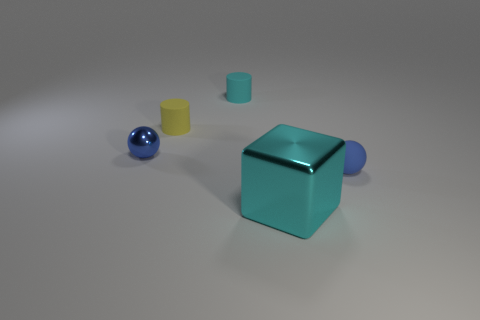How many cyan objects are in front of the yellow matte cylinder and behind the yellow cylinder?
Provide a short and direct response. 0. What number of objects are either cyan things that are in front of the tiny cyan thing or cyan things in front of the blue metallic ball?
Give a very brief answer. 1. What number of other things are there of the same size as the rubber sphere?
Ensure brevity in your answer.  3. There is a shiny thing to the right of the shiny object left of the large metal cube; what is its shape?
Offer a terse response. Cube. There is a metal thing that is behind the rubber ball; does it have the same color as the large metallic cube in front of the blue matte thing?
Provide a succinct answer. No. Are there any other things that are the same color as the large metal cube?
Your answer should be compact. Yes. What color is the small metal ball?
Your answer should be very brief. Blue. Are any large cyan rubber balls visible?
Your answer should be compact. No. There is a tiny yellow matte cylinder; are there any blue shiny objects behind it?
Your answer should be compact. No. There is another object that is the same shape as the small yellow object; what is it made of?
Offer a very short reply. Rubber. 